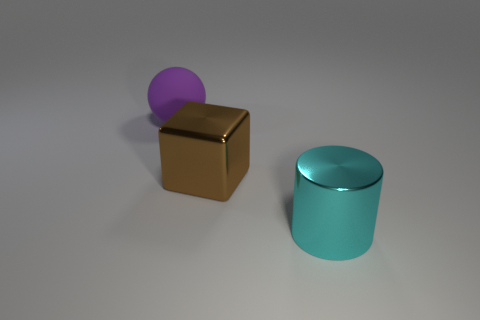Add 3 small purple rubber cylinders. How many objects exist? 6 Subtract all cylinders. How many objects are left? 2 Subtract all brown shiny cubes. Subtract all big metallic cylinders. How many objects are left? 1 Add 3 large rubber things. How many large rubber things are left? 4 Add 3 big brown blocks. How many big brown blocks exist? 4 Subtract 0 blue balls. How many objects are left? 3 